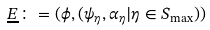<formula> <loc_0><loc_0><loc_500><loc_500>\underline { E } \colon = ( \phi , ( \psi _ { \eta } , \alpha _ { \eta } | \eta \in S _ { \max } ) )</formula> 